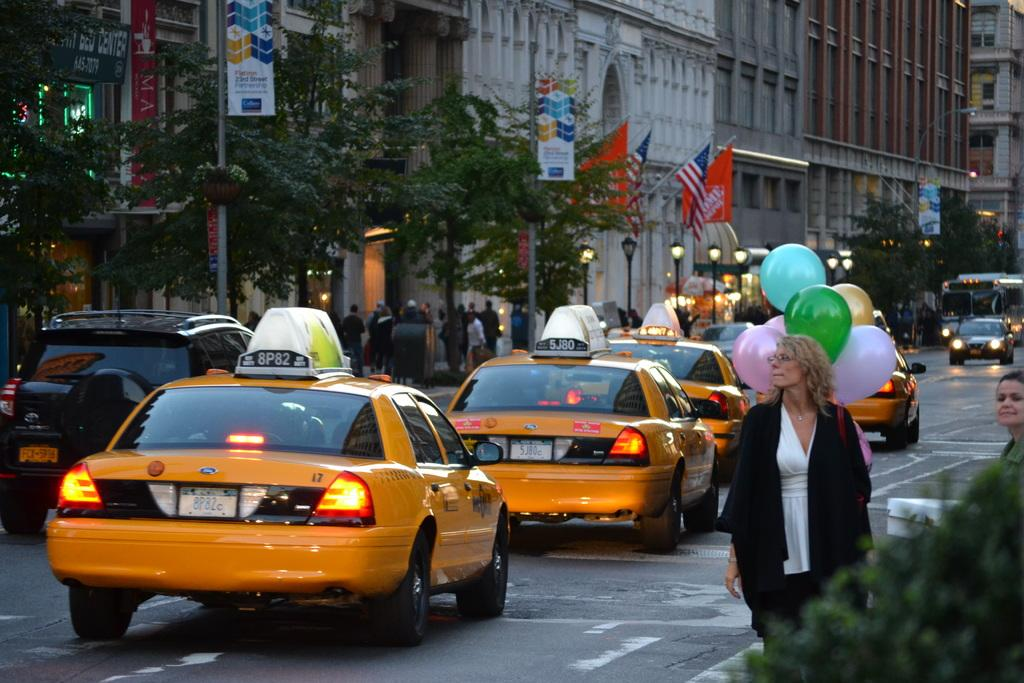Provide a one-sentence caption for the provided image. A taxi is driving on the street with 8P82 on the light on top. 